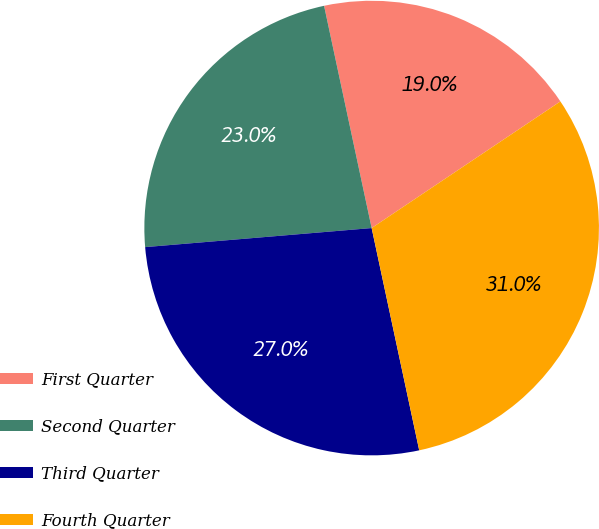Convert chart. <chart><loc_0><loc_0><loc_500><loc_500><pie_chart><fcel>First Quarter<fcel>Second Quarter<fcel>Third Quarter<fcel>Fourth Quarter<nl><fcel>18.95%<fcel>22.98%<fcel>27.02%<fcel>31.05%<nl></chart> 